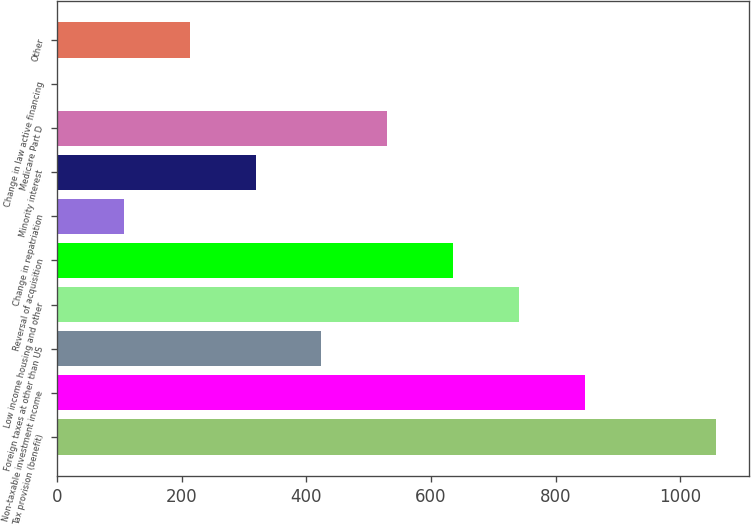Convert chart to OTSL. <chart><loc_0><loc_0><loc_500><loc_500><bar_chart><fcel>Tax provision (benefit)<fcel>Non-taxable investment income<fcel>Foreign taxes at other than US<fcel>Low income housing and other<fcel>Reversal of acquisition<fcel>Change in repatriation<fcel>Minority interest<fcel>Medicare Part D<fcel>Change in law active financing<fcel>Other<nl><fcel>1058<fcel>846.8<fcel>424.4<fcel>741.2<fcel>635.6<fcel>107.6<fcel>318.8<fcel>530<fcel>2<fcel>213.2<nl></chart> 